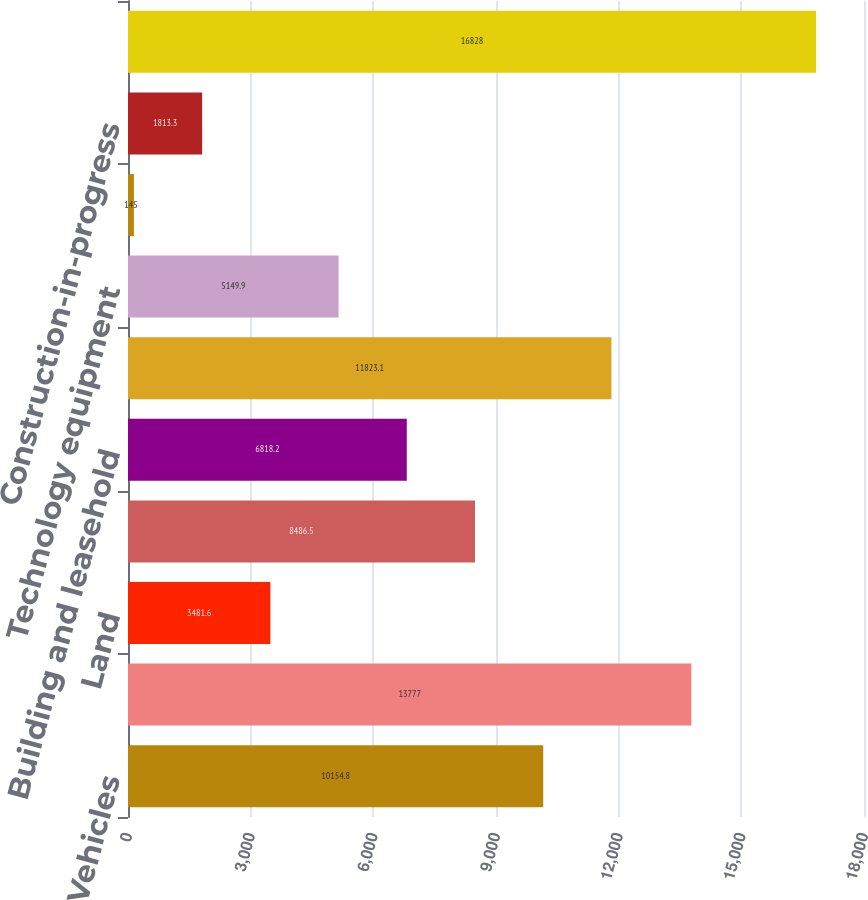<chart> <loc_0><loc_0><loc_500><loc_500><bar_chart><fcel>Vehicles<fcel>Aircraft (including aircraft<fcel>Land<fcel>Buildings<fcel>Building and leasehold<fcel>Plant equipment<fcel>Technology equipment<fcel>Equipment under operating<fcel>Construction-in-progress<fcel>Less Accumulated depreciation<nl><fcel>10154.8<fcel>13777<fcel>3481.6<fcel>8486.5<fcel>6818.2<fcel>11823.1<fcel>5149.9<fcel>145<fcel>1813.3<fcel>16828<nl></chart> 